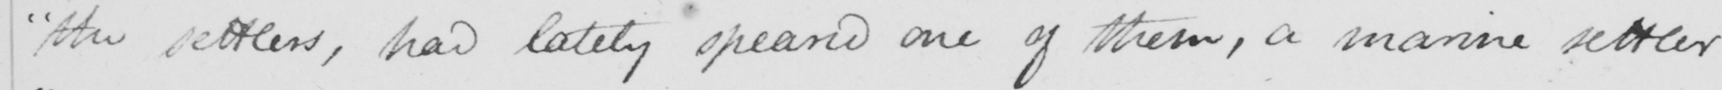Please provide the text content of this handwritten line. " the settlers , has lately speared one of them , a marine settler 